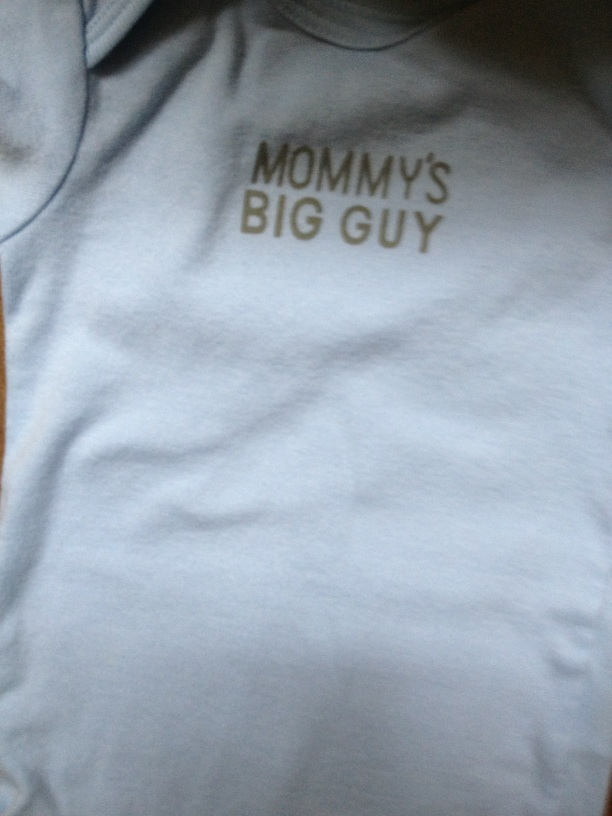What could be a very creative next question to ask about the shirt?  If this shirt had magical powers, what would they be and how would it affect the baby's life? If this shirt had magical powers, it could give the baby amazing abilities! Imagine the shirt granting the baby super strength, making him truly 'Mommy's Big Guy,' able to lift toys and move around effortlessly. Perhaps the shirt could make the baby understand and communicate thoughts, even having wise conversations with everyone around him. This magical shirt could turn ordinary days into extraordinary adventures, with the baby becoming a tiny superhero in his family, spreading joy and inspiration! 